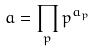Convert formula to latex. <formula><loc_0><loc_0><loc_500><loc_500>a = \prod _ { p } p ^ { a _ { p } }</formula> 